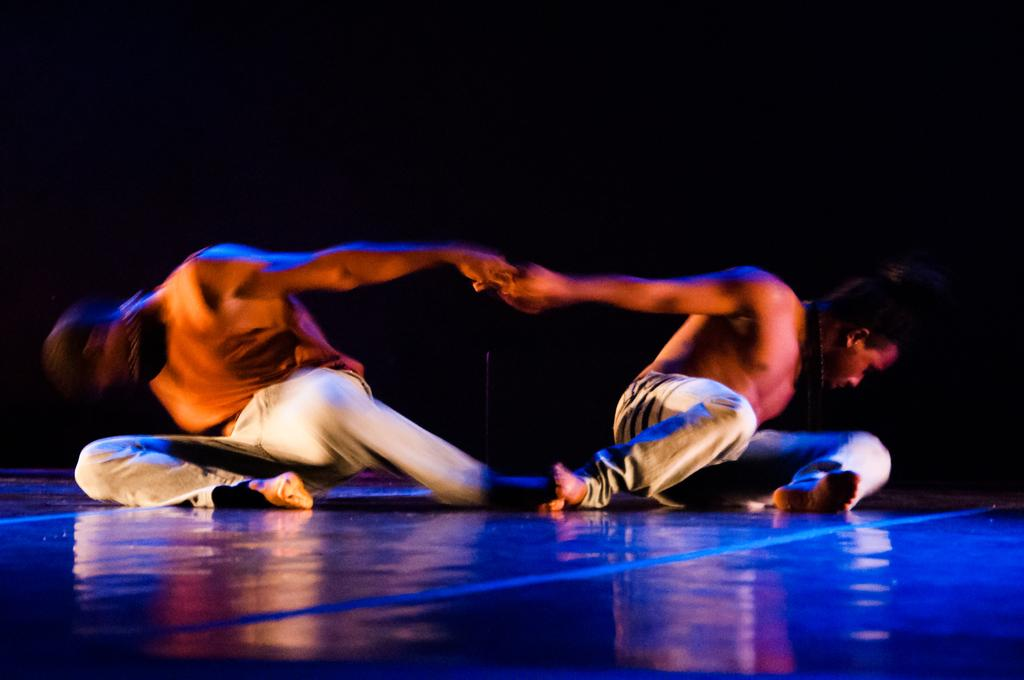How many people are present in the image? There are two people in the image. What might the people be doing in the image? The people might be dancing. What is the surface that the people are standing on in the image? There is a floor visible in the image. What color is the background of the image? The background of the image is black. Where is the nest located in the image? There is no nest present in the image. How many eggs are visible in the image? There are no eggs visible in the image. 